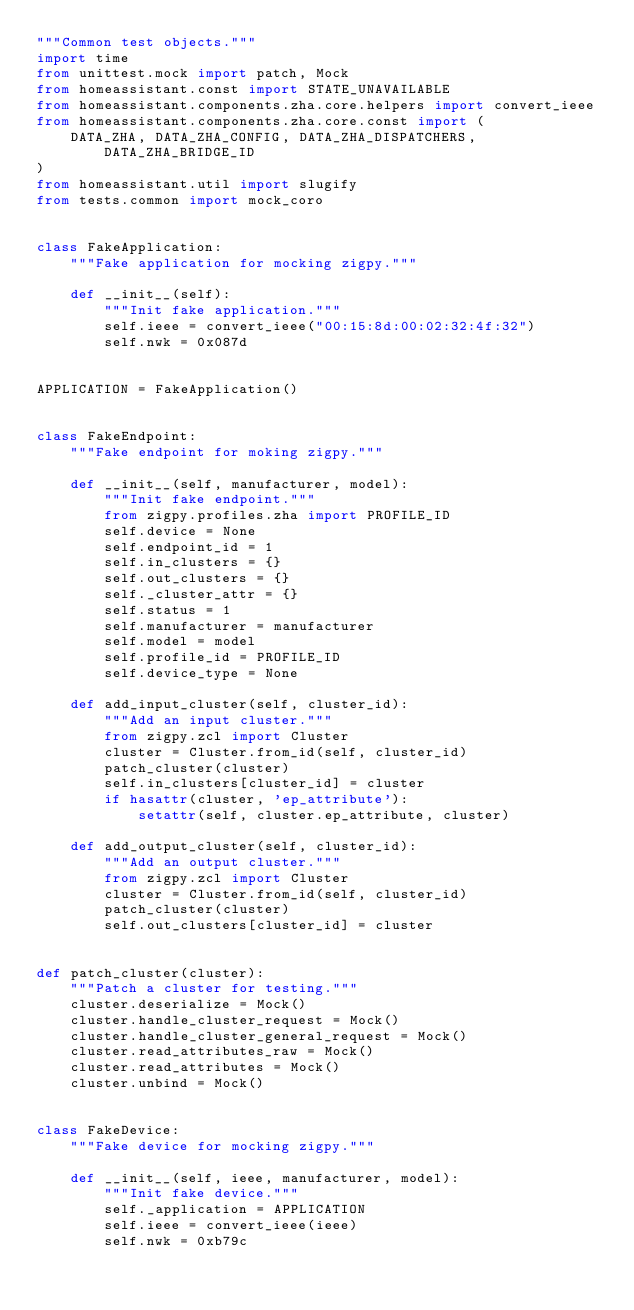<code> <loc_0><loc_0><loc_500><loc_500><_Python_>"""Common test objects."""
import time
from unittest.mock import patch, Mock
from homeassistant.const import STATE_UNAVAILABLE
from homeassistant.components.zha.core.helpers import convert_ieee
from homeassistant.components.zha.core.const import (
    DATA_ZHA, DATA_ZHA_CONFIG, DATA_ZHA_DISPATCHERS, DATA_ZHA_BRIDGE_ID
)
from homeassistant.util import slugify
from tests.common import mock_coro


class FakeApplication:
    """Fake application for mocking zigpy."""

    def __init__(self):
        """Init fake application."""
        self.ieee = convert_ieee("00:15:8d:00:02:32:4f:32")
        self.nwk = 0x087d


APPLICATION = FakeApplication()


class FakeEndpoint:
    """Fake endpoint for moking zigpy."""

    def __init__(self, manufacturer, model):
        """Init fake endpoint."""
        from zigpy.profiles.zha import PROFILE_ID
        self.device = None
        self.endpoint_id = 1
        self.in_clusters = {}
        self.out_clusters = {}
        self._cluster_attr = {}
        self.status = 1
        self.manufacturer = manufacturer
        self.model = model
        self.profile_id = PROFILE_ID
        self.device_type = None

    def add_input_cluster(self, cluster_id):
        """Add an input cluster."""
        from zigpy.zcl import Cluster
        cluster = Cluster.from_id(self, cluster_id)
        patch_cluster(cluster)
        self.in_clusters[cluster_id] = cluster
        if hasattr(cluster, 'ep_attribute'):
            setattr(self, cluster.ep_attribute, cluster)

    def add_output_cluster(self, cluster_id):
        """Add an output cluster."""
        from zigpy.zcl import Cluster
        cluster = Cluster.from_id(self, cluster_id)
        patch_cluster(cluster)
        self.out_clusters[cluster_id] = cluster


def patch_cluster(cluster):
    """Patch a cluster for testing."""
    cluster.deserialize = Mock()
    cluster.handle_cluster_request = Mock()
    cluster.handle_cluster_general_request = Mock()
    cluster.read_attributes_raw = Mock()
    cluster.read_attributes = Mock()
    cluster.unbind = Mock()


class FakeDevice:
    """Fake device for mocking zigpy."""

    def __init__(self, ieee, manufacturer, model):
        """Init fake device."""
        self._application = APPLICATION
        self.ieee = convert_ieee(ieee)
        self.nwk = 0xb79c</code> 